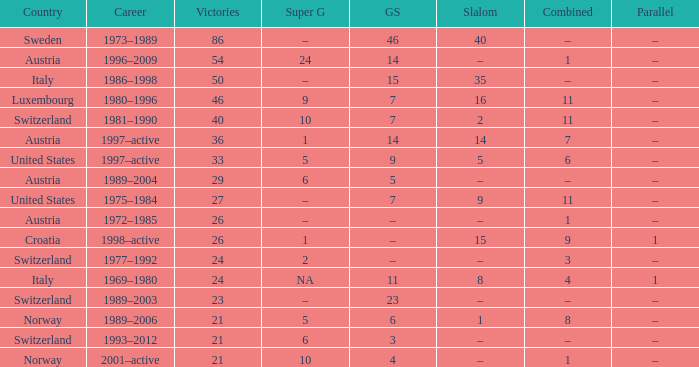Parse the full table. {'header': ['Country', 'Career', 'Victories', 'Super G', 'GS', 'Slalom', 'Combined', 'Parallel'], 'rows': [['Sweden', '1973–1989', '86', '–', '46', '40', '–', '–'], ['Austria', '1996–2009', '54', '24', '14', '–', '1', '–'], ['Italy', '1986–1998', '50', '–', '15', '35', '–', '–'], ['Luxembourg', '1980–1996', '46', '9', '7', '16', '11', '–'], ['Switzerland', '1981–1990', '40', '10', '7', '2', '11', '–'], ['Austria', '1997–active', '36', '1', '14', '14', '7', '–'], ['United States', '1997–active', '33', '5', '9', '5', '6', '–'], ['Austria', '1989–2004', '29', '6', '5', '–', '–', '–'], ['United States', '1975–1984', '27', '–', '7', '9', '11', '–'], ['Austria', '1972–1985', '26', '–', '–', '–', '1', '–'], ['Croatia', '1998–active', '26', '1', '–', '15', '9', '1'], ['Switzerland', '1977–1992', '24', '2', '–', '–', '3', '–'], ['Italy', '1969–1980', '24', 'NA', '11', '8', '4', '1'], ['Switzerland', '1989–2003', '23', '–', '23', '–', '–', '–'], ['Norway', '1989–2006', '21', '5', '6', '1', '8', '–'], ['Switzerland', '1993–2012', '21', '6', '3', '–', '–', '–'], ['Norway', '2001–active', '21', '10', '4', '–', '1', '–']]} What Super G has Victories of 26, and a Country of austria? –. 